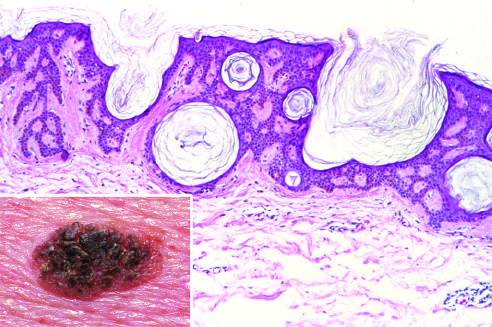does low magnification show an orderly proliferation of uniform, basaloid keratinocytes that tend to form keratin microcysts horn cysts?
Answer the question using a single word or phrase. No 